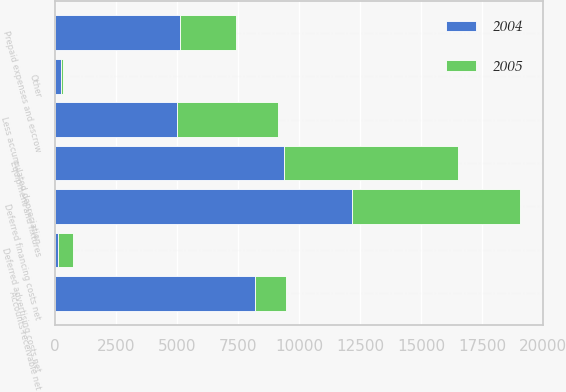Convert chart to OTSL. <chart><loc_0><loc_0><loc_500><loc_500><stacked_bar_chart><ecel><fcel>Equipment and fixtures<fcel>Less accumulated depreciation<fcel>Deferred financing costs net<fcel>Deferred advertising costs net<fcel>Prepaid expenses and escrow<fcel>Accounts receivable net<fcel>Other<nl><fcel>2004<fcel>9389<fcel>4977<fcel>12151<fcel>128<fcel>5114<fcel>8179<fcel>224<nl><fcel>2005<fcel>7115<fcel>4136<fcel>6899<fcel>588<fcel>2305<fcel>1295<fcel>77<nl></chart> 